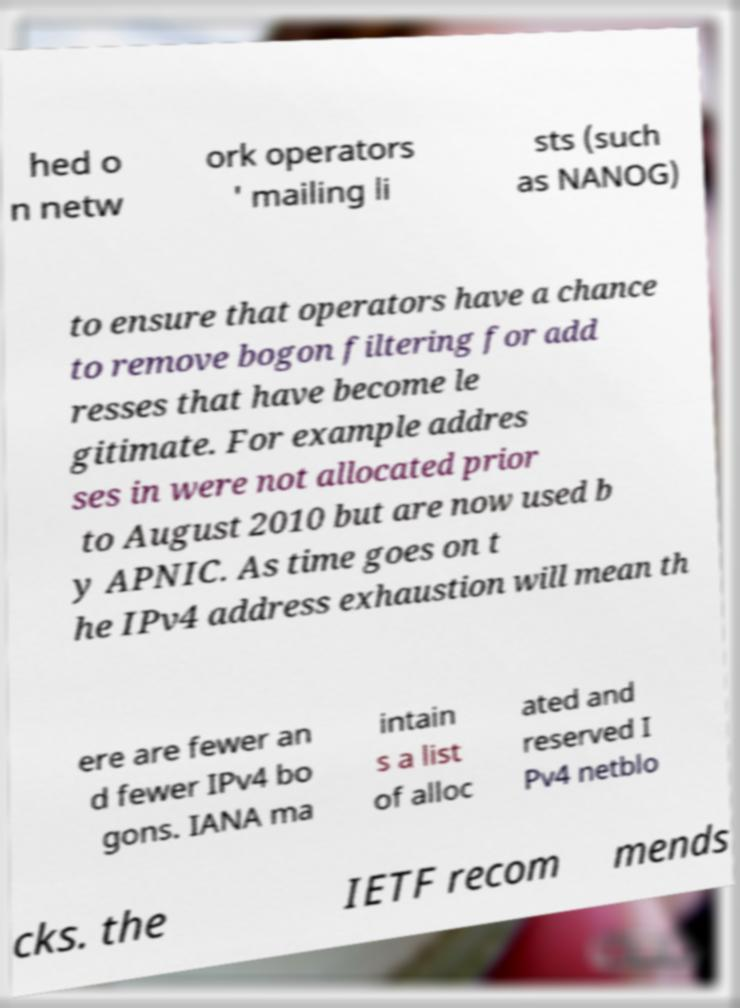Could you assist in decoding the text presented in this image and type it out clearly? hed o n netw ork operators ' mailing li sts (such as NANOG) to ensure that operators have a chance to remove bogon filtering for add resses that have become le gitimate. For example addres ses in were not allocated prior to August 2010 but are now used b y APNIC. As time goes on t he IPv4 address exhaustion will mean th ere are fewer an d fewer IPv4 bo gons. IANA ma intain s a list of alloc ated and reserved I Pv4 netblo cks. the IETF recom mends 